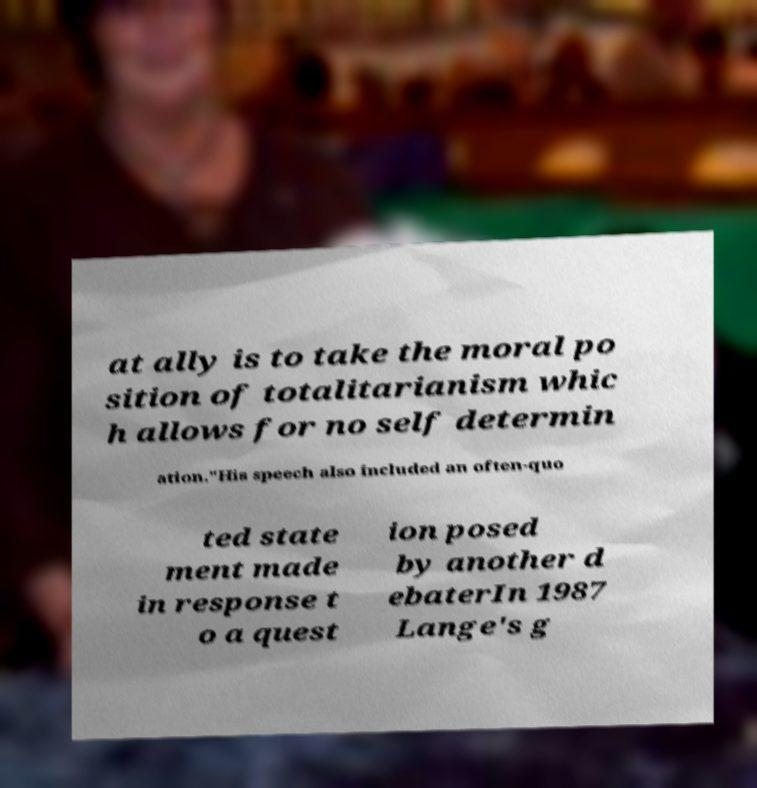Can you accurately transcribe the text from the provided image for me? at ally is to take the moral po sition of totalitarianism whic h allows for no self determin ation."His speech also included an often-quo ted state ment made in response t o a quest ion posed by another d ebaterIn 1987 Lange's g 